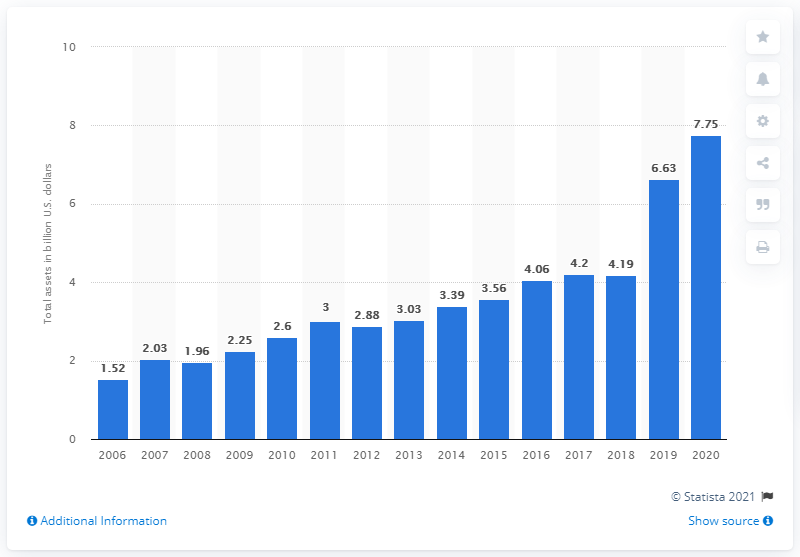Give some essential details in this illustration. In the financial year of 2020, the total assets of Dick's Sporting Goods were 7.75 billion dollars. 